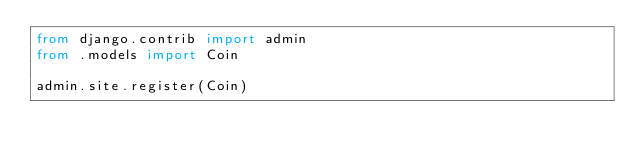Convert code to text. <code><loc_0><loc_0><loc_500><loc_500><_Python_>from django.contrib import admin
from .models import Coin

admin.site.register(Coin)
</code> 